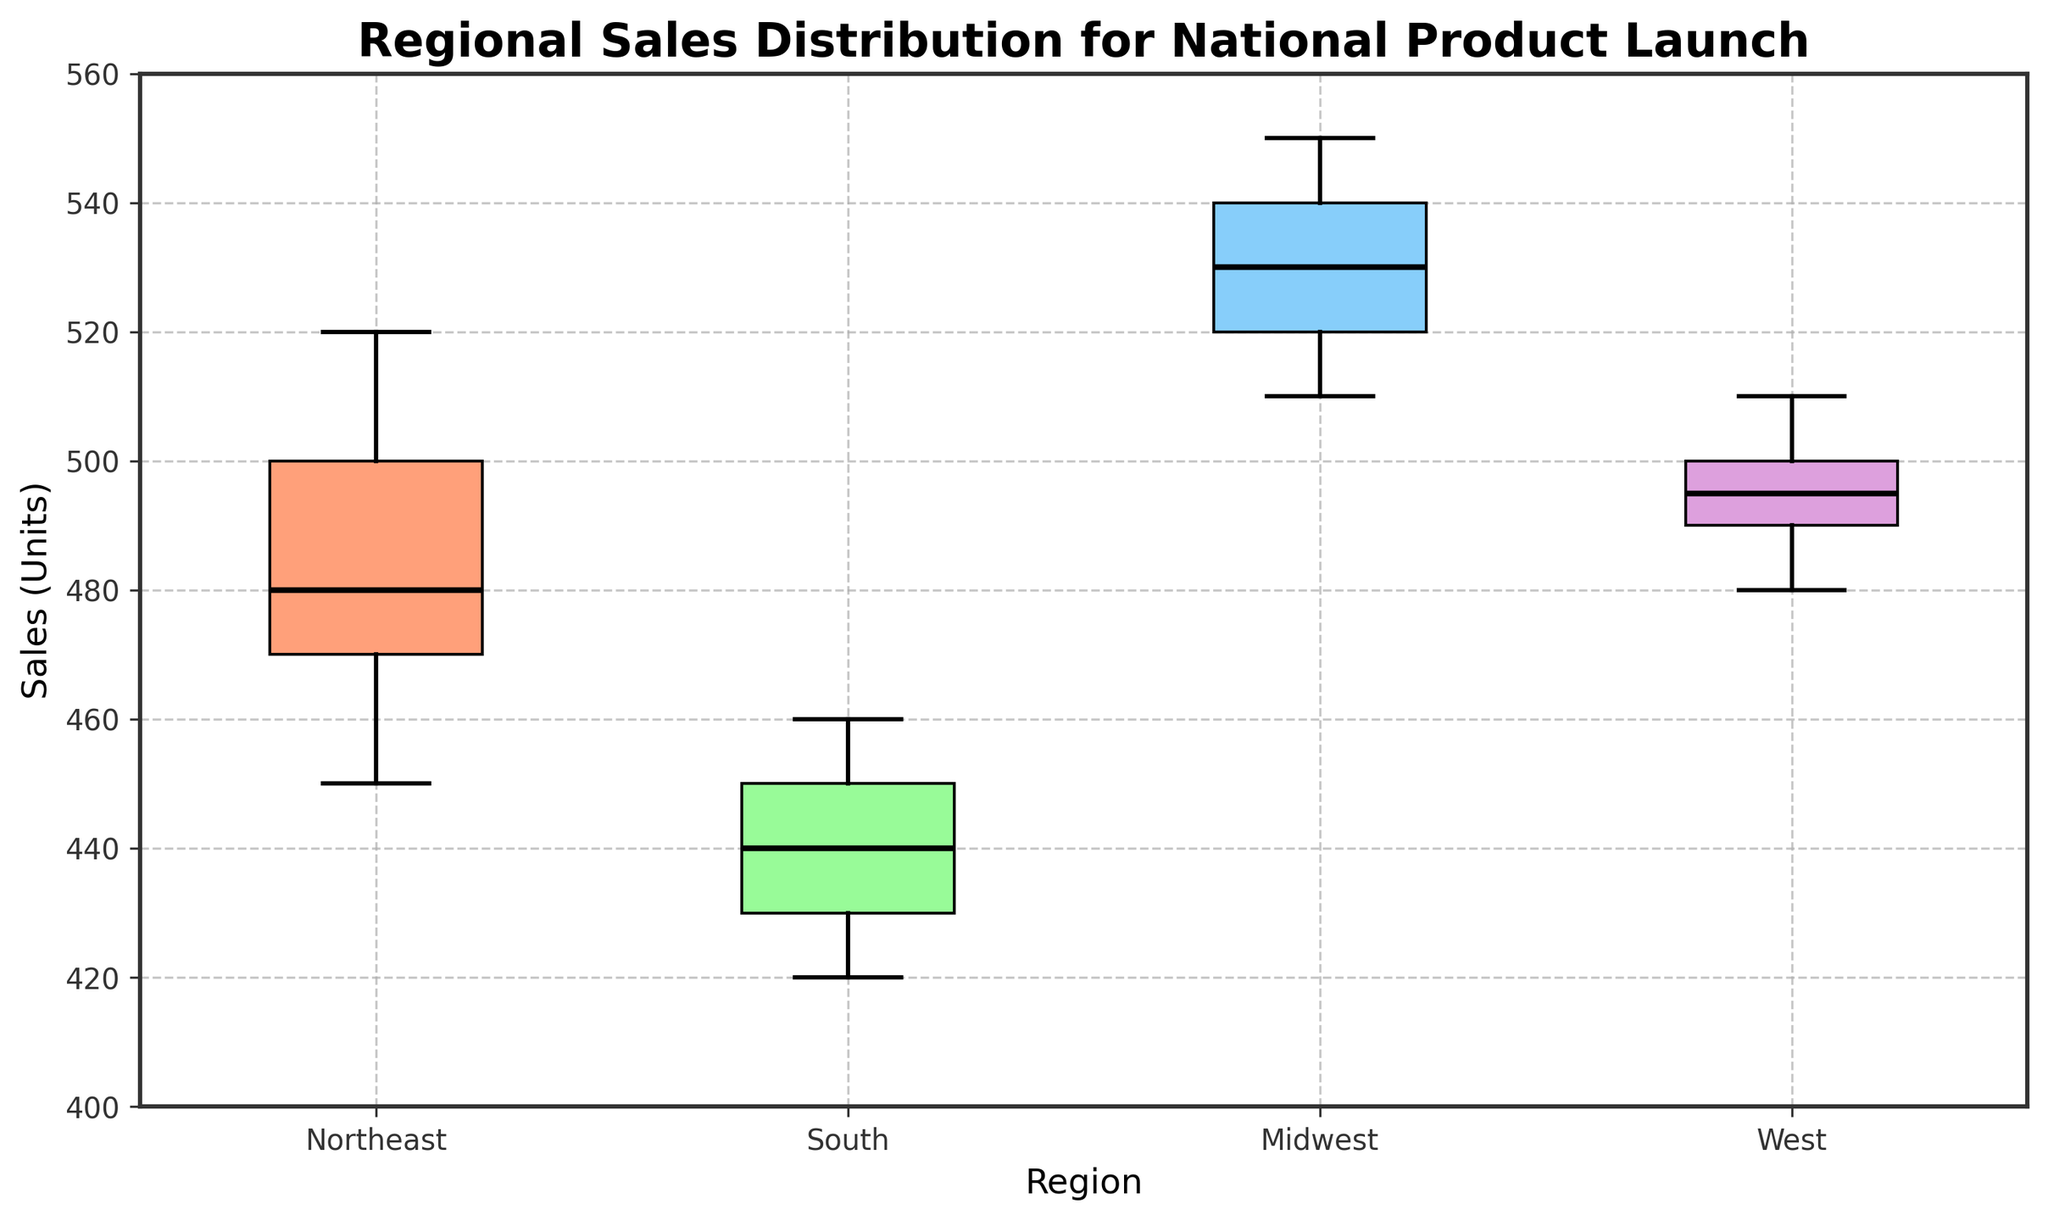what is the title of the box plot? The title is located at the top of the plot. It reads "Regional Sales Distribution for National Product Launch".
Answer: Regional Sales Distribution for National Product Launch What regions are compared in the box plot? The regions are listed under each box on the x-axis. These regions are Northeast, South, Midwest, and West.
Answer: Northeast, South, Midwest, West Which region has the highest median sales? The median is indicated by the thick black line inside each box. The Midwest region's median line is the highest.
Answer: Midwest What is the range of sales for the Northeast region based on the box plot? The range is determined by the length of the box and the whiskers. For the Northeast, it starts from 450 (lower whisker) to 520 (upper whisker).
Answer: 450 to 520 How does the interquartile range (IQR) for the South compare to the West? The IQR is visualized by the height of the box. The box for the West is slightly taller than the box for the South, indicating a larger IQR.
Answer: West IQR is larger Which region has the least variability in sales figures? Variability can be assessed by the height of the boxes and whiskers. The narrowest box, representing the least variability, belongs to the Northeast region.
Answer: Northeast What is the median sales value for the West region? The median sales value can be read from the thick black line inside the box for the West region. It is approximately 495 units.
Answer: 495 units Which region shows the widest range between the maximum and minimum sales values? The widest range can be identified by the total height from the lowest whisker to the highest whisker. The highest range is observed in the Midwest region.
Answer: Midwest What is the difference between the median sales of the Midwest and South regions? The median value for Midwest is around 530 units and for South, it is around 440 units. The difference is 530 - 440 = 90.
Answer: 90 units How does the upper quartile of the Northeast compare to the South's upper quartile? The upper quartile is represented by the top edge of the box. The Northeast's upper quartile is higher than the South's upper quartile.
Answer: Northeast's quartile is higher 